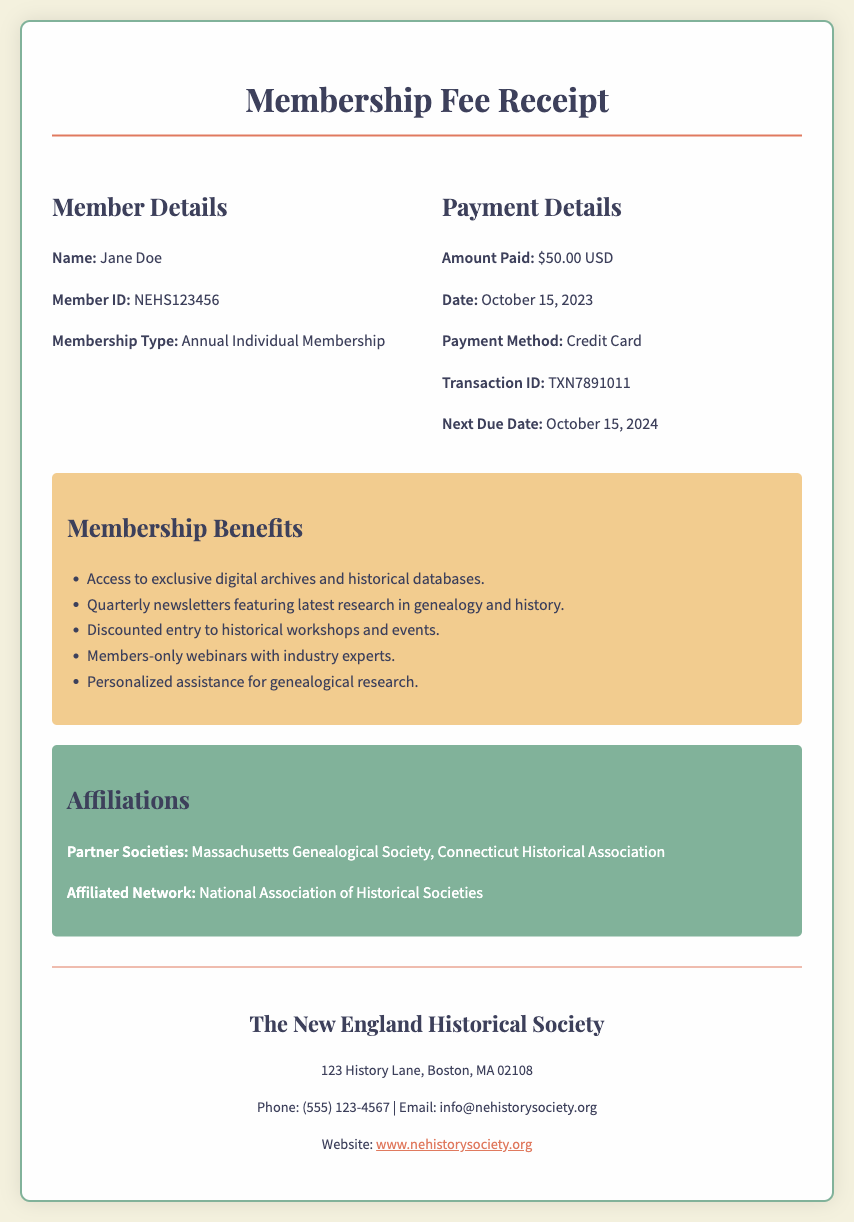What is the member’s name? The name of the member is stated in the Member Details section of the document.
Answer: Jane Doe What is the membership type? The membership type can be found in the Member Details section.
Answer: Annual Individual Membership What was the payment amount? The payment amount is clearly indicated in the Payment Details section.
Answer: $50.00 USD When was the payment made? The payment date is listed under Payment Details.
Answer: October 15, 2023 What is the transaction ID? The transaction ID is found in the Payment Details section.
Answer: TXN7891011 What are two benefits of becoming a member? Several benefits listed in the Membership Benefits section provide member advantages.
Answer: Access to exclusive digital archives and discounted entry to historical workshops What is the next due date for payment? The next due date is mentioned under Payment Details.
Answer: October 15, 2024 Which societies are listed as partner societies? The partner societies are specified in the Affiliations section of the document.
Answer: Massachusetts Genealogical Society, Connecticut Historical Association What is the contact email for the society? The contact email is provided in the contact information section of the document.
Answer: info@nehistorysociety.org 